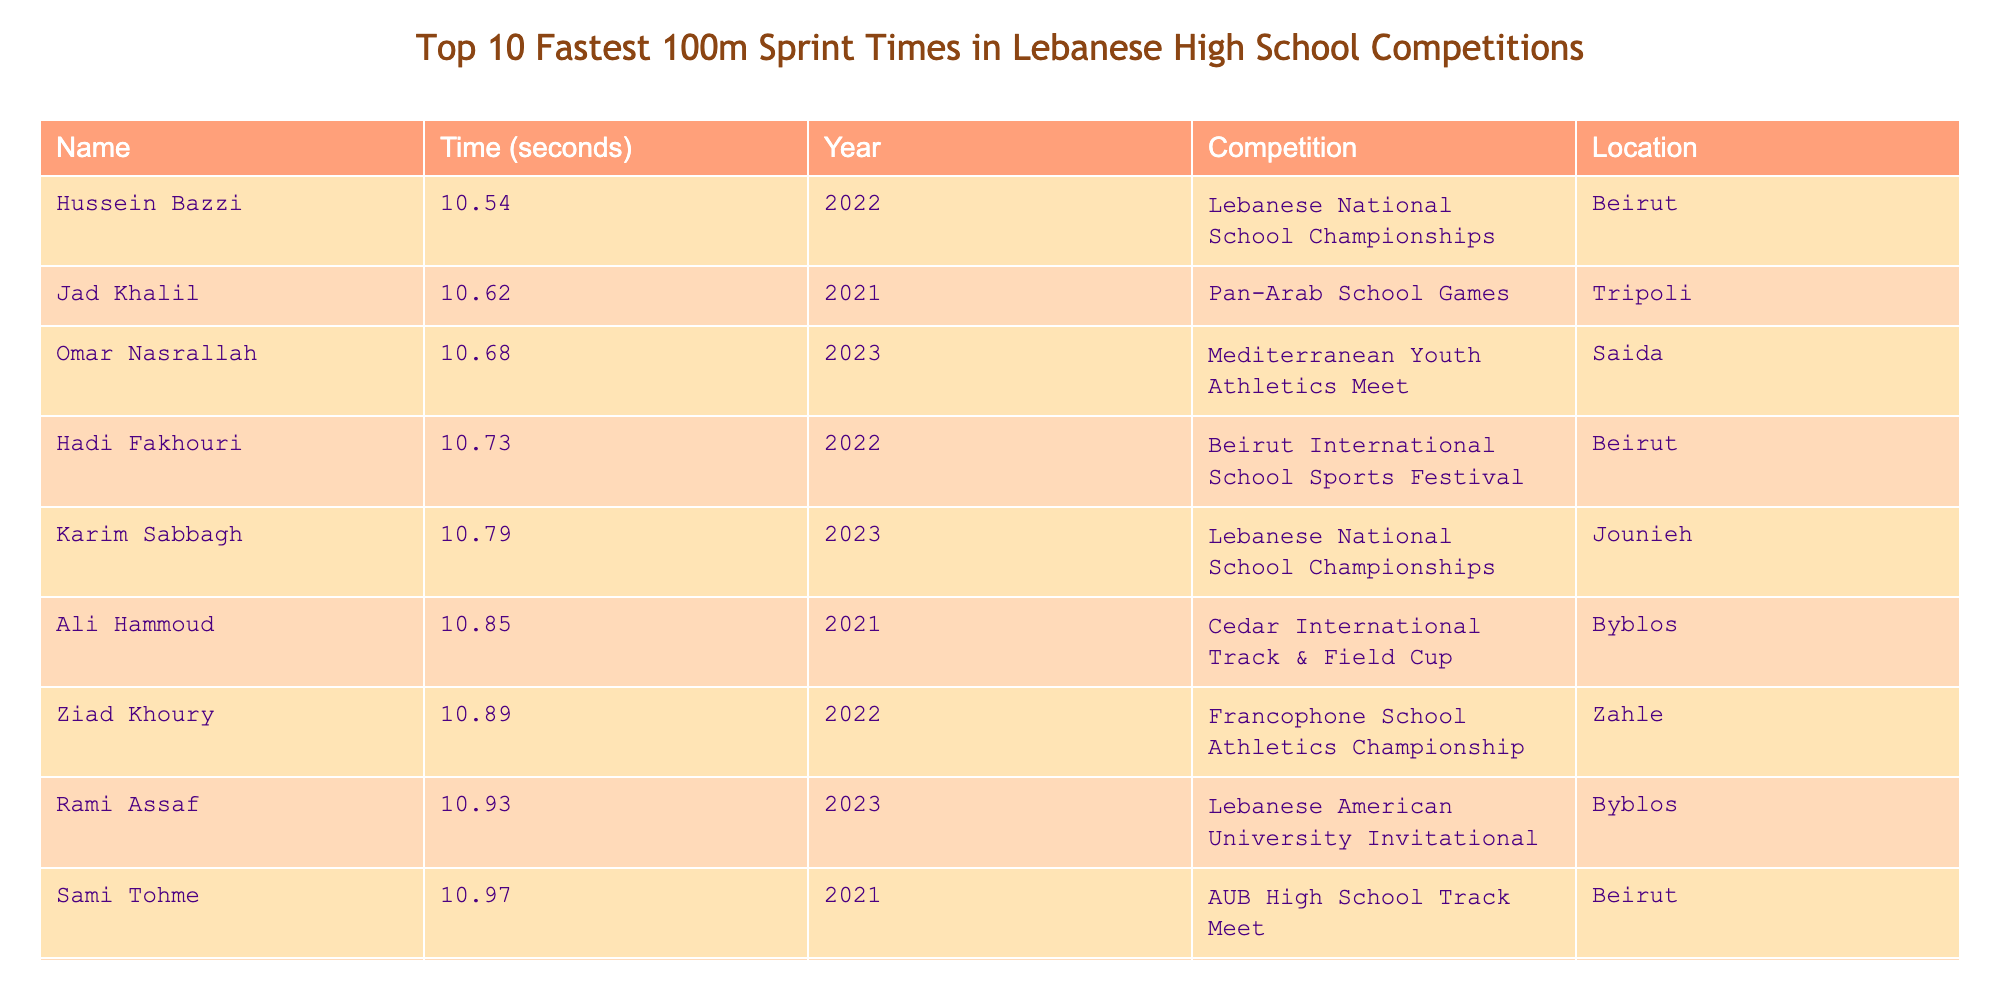What is the fastest recorded time in the table? The fastest time listed is 10.54 seconds, attributed to Hussein Bazzi in 2022.
Answer: 10.54 seconds Who achieved the fastest time and in which competition? Hussein Bazzi has the fastest time of 10.54 seconds, achieved at the Lebanese National School Championships in 2022.
Answer: Hussein Bazzi at the Lebanese National School Championships Which year saw the second-fastest time? The second-fastest time is 10.62 seconds by Jad Khalil in 2021.
Answer: 2021 What is the average time of the top three fastest sprint times? The top three times are 10.54, 10.62, and 10.68 seconds. Their average is (10.54 + 10.62 + 10.68) / 3 = 10.613 seconds.
Answer: 10.613 seconds Did any competitor achieve a time under 10.80 seconds? Yes, there are four competitors who achieved times under 10.80 seconds: Hussein Bazzi, Jad Khalil, Omar Nasrallah, and Hadi Fakhouri.
Answer: Yes How many competitors recorded times faster than 11 seconds? There are six competitors who recorded times faster than 11 seconds: Hussein Bazzi, Jad Khalil, Omar Nasrallah, Hadi Fakhouri, Karim Sabbagh, and Ali Hammoud.
Answer: 6 What is the difference between the fastest and the slowest recorded times? The fastest time is 10.54 seconds and the slowest time is 11.01 seconds. The difference is 11.01 - 10.54 = 0.47 seconds.
Answer: 0.47 seconds In which locations were these competitions held? The table lists competitions held in Beirut, Tripoli, Saida, Jounieh, and Byblos, among others.
Answer: Beirut, Tripoli, Saida, Jounieh, Byblos Which competition had the most competitors listed? The Lebanese National School Championships had two competitors listed, which is the most for any single competition in the table.
Answer: Lebanese National School Championships Is there a competitor who participated in multiple competitions listed? No, each competitor in the list participated in a unique competition without repetition.
Answer: No 